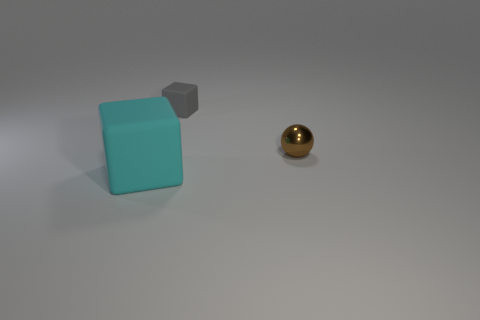Add 1 big purple things. How many objects exist? 4 Subtract 1 spheres. How many spheres are left? 0 Subtract all gray cubes. Subtract all cyan cylinders. How many cubes are left? 1 Subtract all gray blocks. How many purple balls are left? 0 Subtract all small cubes. Subtract all small shiny objects. How many objects are left? 1 Add 2 big cyan rubber objects. How many big cyan rubber objects are left? 3 Add 1 gray objects. How many gray objects exist? 2 Subtract 0 yellow spheres. How many objects are left? 3 Subtract all cubes. How many objects are left? 1 